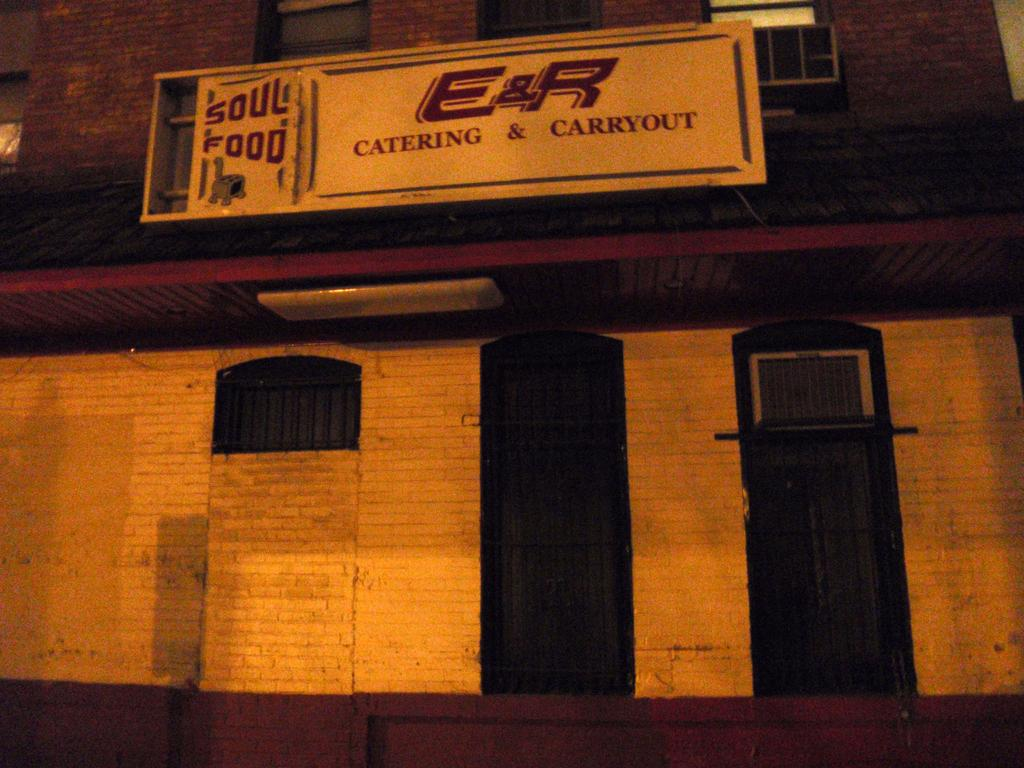What is the main structure in the center of the image? There is a building in the center of the image. What are some features of the building that can be seen in the image? There are doors in the image. What else is present in the image besides the building? There is a board in the image. What can be read or observed on the board? There is text on the board. Is there a fire visible in the image? No, there is no fire present in the image. What type of crime is being committed in the image? There is no crime depicted in the image; it only shows a building, doors, and a board with text. 